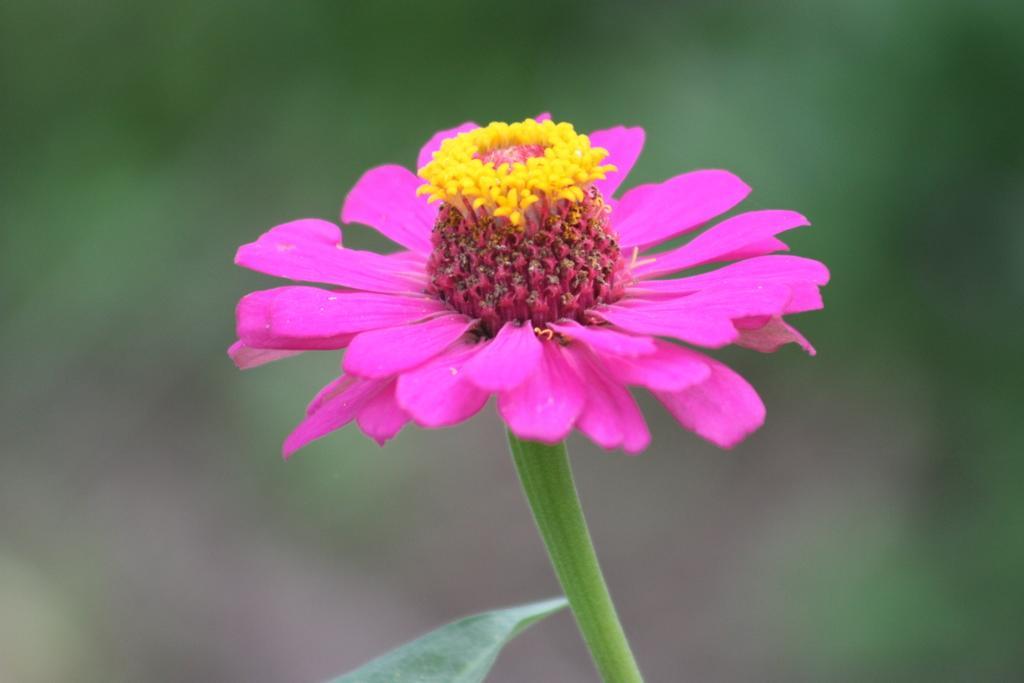How would you summarize this image in a sentence or two? In this picture, we see a flower and this flower is in pink and yellow color. In the background, it is green in color and this picture is blurred in the background. 